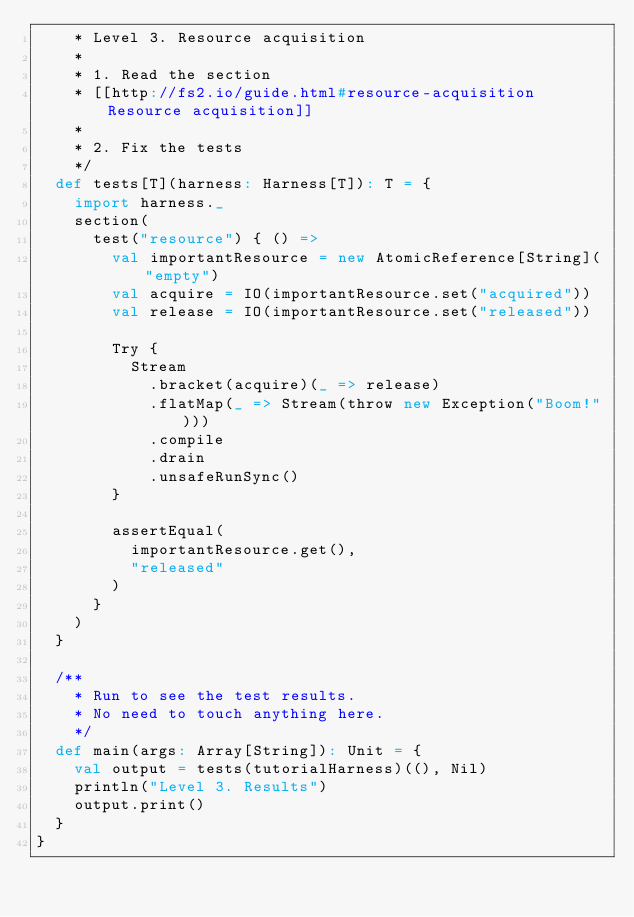Convert code to text. <code><loc_0><loc_0><loc_500><loc_500><_Scala_>    * Level 3. Resource acquisition
    *
    * 1. Read the section
    * [[http://fs2.io/guide.html#resource-acquisition Resource acquisition]]
    *
    * 2. Fix the tests
    */
  def tests[T](harness: Harness[T]): T = {
    import harness._
    section(
      test("resource") { () =>
        val importantResource = new AtomicReference[String]("empty")
        val acquire = IO(importantResource.set("acquired"))
        val release = IO(importantResource.set("released"))

        Try {
          Stream
            .bracket(acquire)(_ => release)
            .flatMap(_ => Stream(throw new Exception("Boom!")))
            .compile
            .drain
            .unsafeRunSync()
        }

        assertEqual(
          importantResource.get(),
          "released"
        )
      }
    )
  }

  /**
    * Run to see the test results.
    * No need to touch anything here.
    */
  def main(args: Array[String]): Unit = {
    val output = tests(tutorialHarness)((), Nil)
    println("Level 3. Results")
    output.print()
  }
}
</code> 